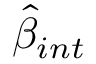Convert formula to latex. <formula><loc_0><loc_0><loc_500><loc_500>\hat { \beta } _ { i n t }</formula> 